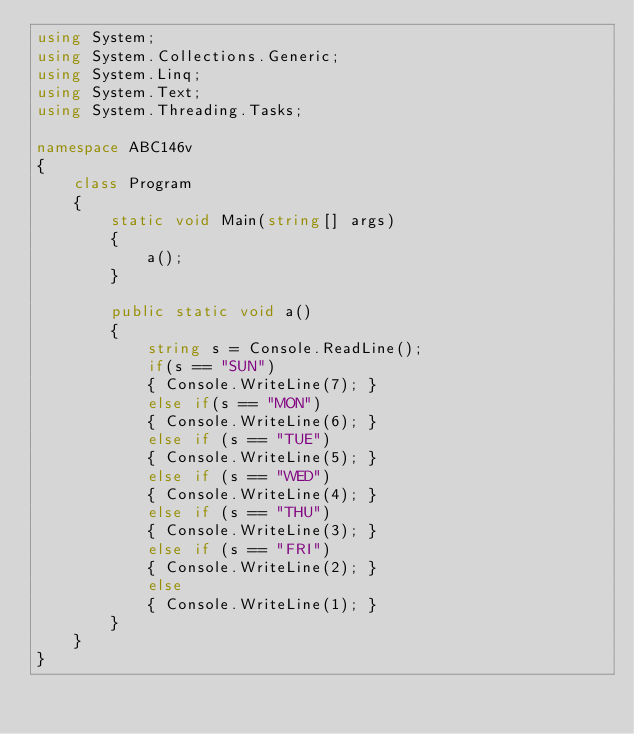Convert code to text. <code><loc_0><loc_0><loc_500><loc_500><_C#_>using System;
using System.Collections.Generic;
using System.Linq;
using System.Text;
using System.Threading.Tasks;

namespace ABC146v
{
    class Program
    {
        static void Main(string[] args)
        {
            a();
        }

        public static void a()
        {
            string s = Console.ReadLine();
            if(s == "SUN")
            { Console.WriteLine(7); }
            else if(s == "MON")
            { Console.WriteLine(6); }
            else if (s == "TUE")
            { Console.WriteLine(5); }
            else if (s == "WED")
            { Console.WriteLine(4); }
            else if (s == "THU")
            { Console.WriteLine(3); }
            else if (s == "FRI")
            { Console.WriteLine(2); }
            else
            { Console.WriteLine(1); }
        }
    }
}
</code> 